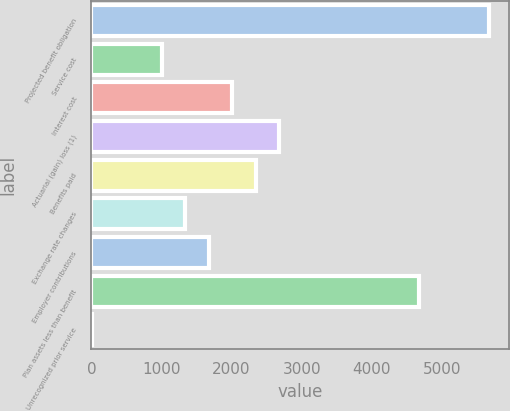Convert chart. <chart><loc_0><loc_0><loc_500><loc_500><bar_chart><fcel>Projected benefit obligation<fcel>Service cost<fcel>Interest cost<fcel>Actuarial (gain) loss (1)<fcel>Benefits paid<fcel>Exchange rate changes<fcel>Employer contributions<fcel>Plan assets less than benefit<fcel>Unrecognized prior service<nl><fcel>5677.2<fcel>1006.8<fcel>2007.6<fcel>2674.8<fcel>2341.2<fcel>1340.4<fcel>1674<fcel>4676.4<fcel>6<nl></chart> 